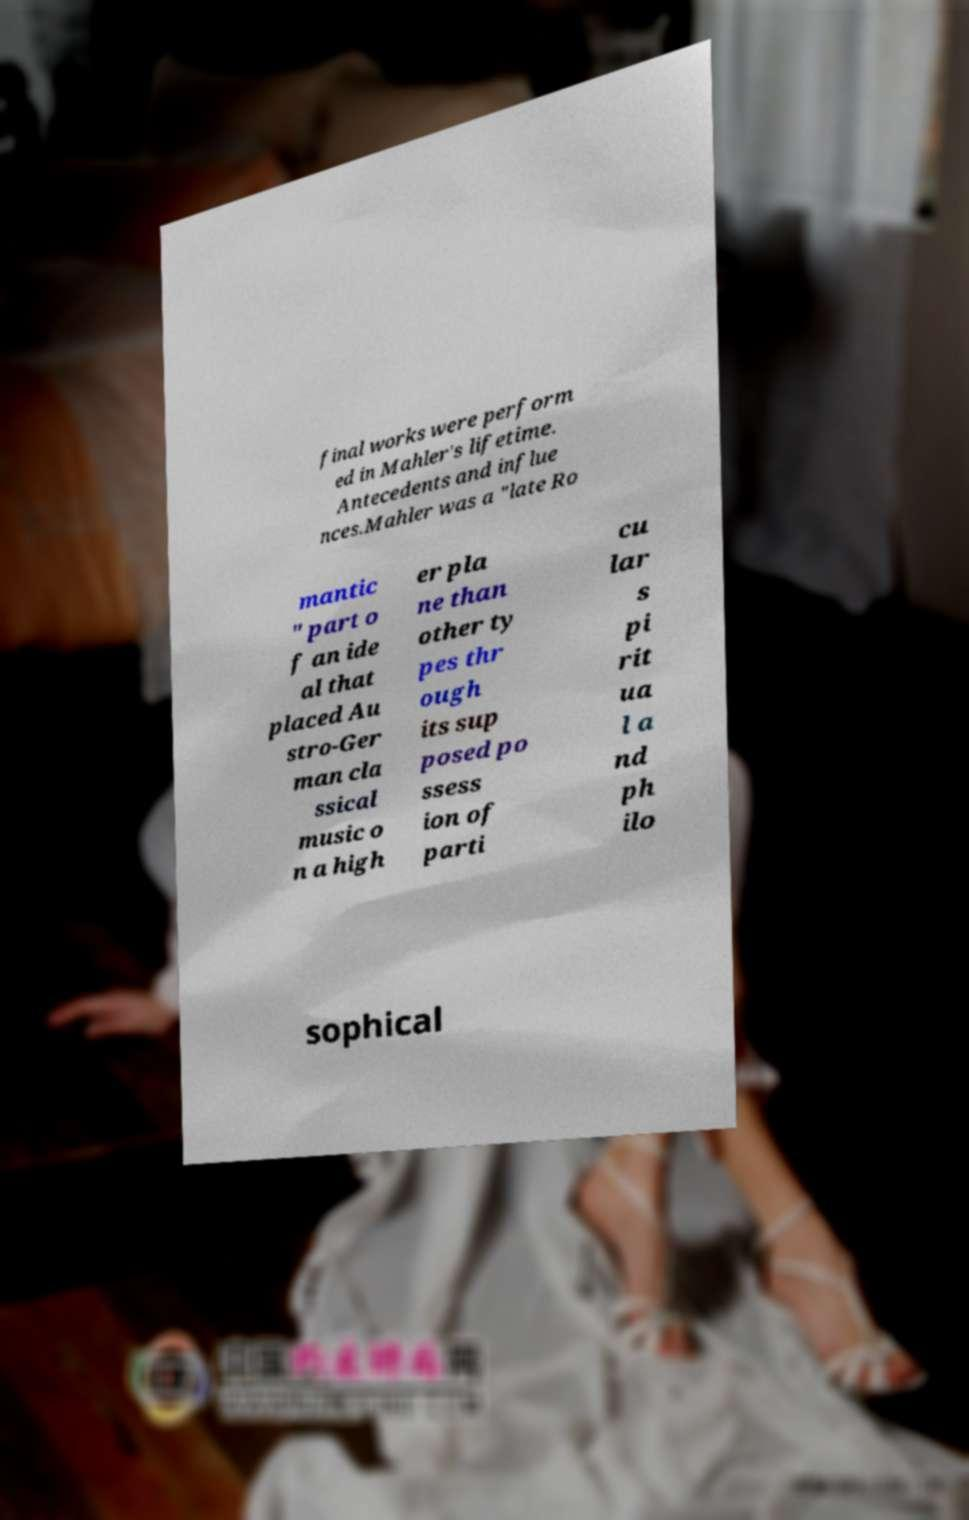Could you assist in decoding the text presented in this image and type it out clearly? final works were perform ed in Mahler's lifetime. Antecedents and influe nces.Mahler was a "late Ro mantic " part o f an ide al that placed Au stro-Ger man cla ssical music o n a high er pla ne than other ty pes thr ough its sup posed po ssess ion of parti cu lar s pi rit ua l a nd ph ilo sophical 